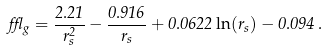<formula> <loc_0><loc_0><loc_500><loc_500>\epsilon _ { g } = \frac { 2 . 2 1 } { r _ { s } ^ { 2 } } - \frac { 0 . 9 1 6 } { r _ { s } } + 0 . 0 6 2 2 \ln ( r _ { s } ) - 0 . 0 9 4 \, .</formula> 